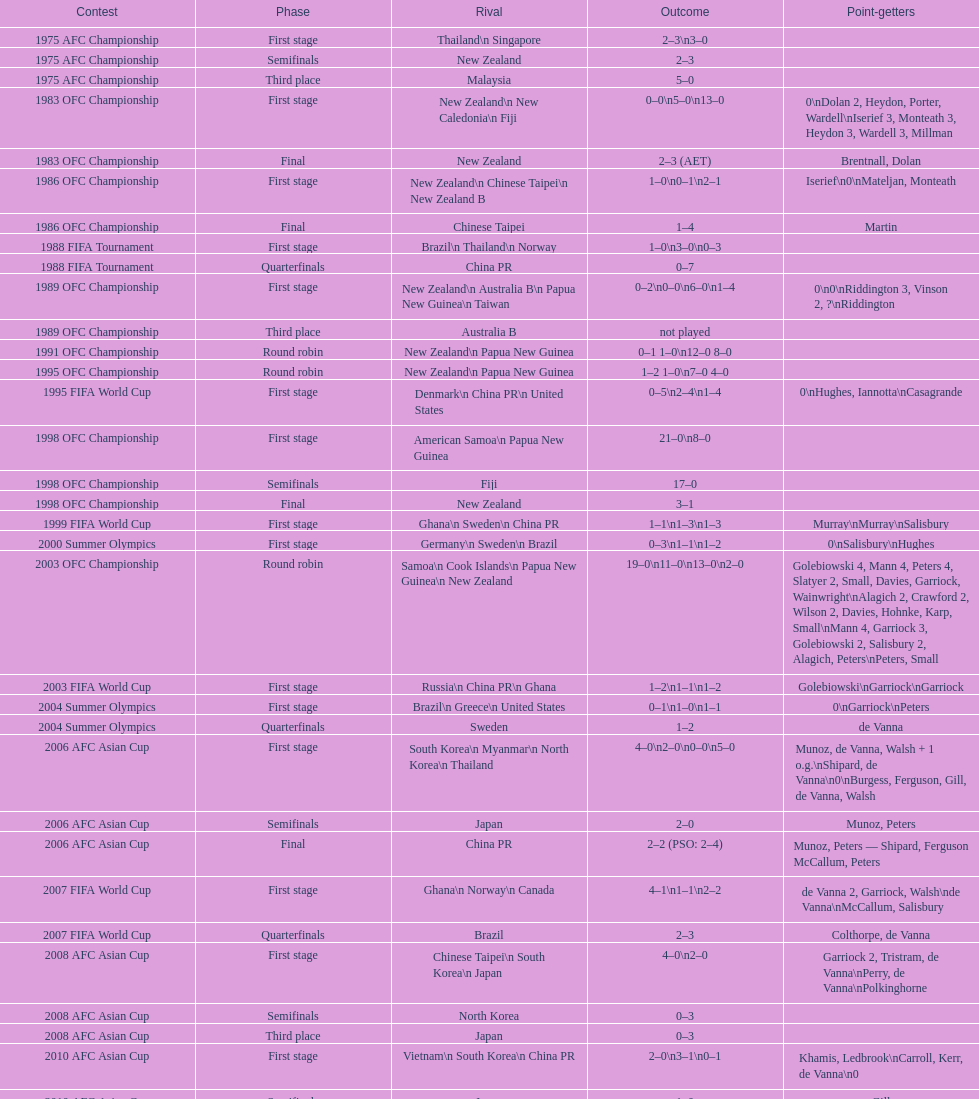Who scored better in the 1995 fifa world cup denmark or the united states? United States. 